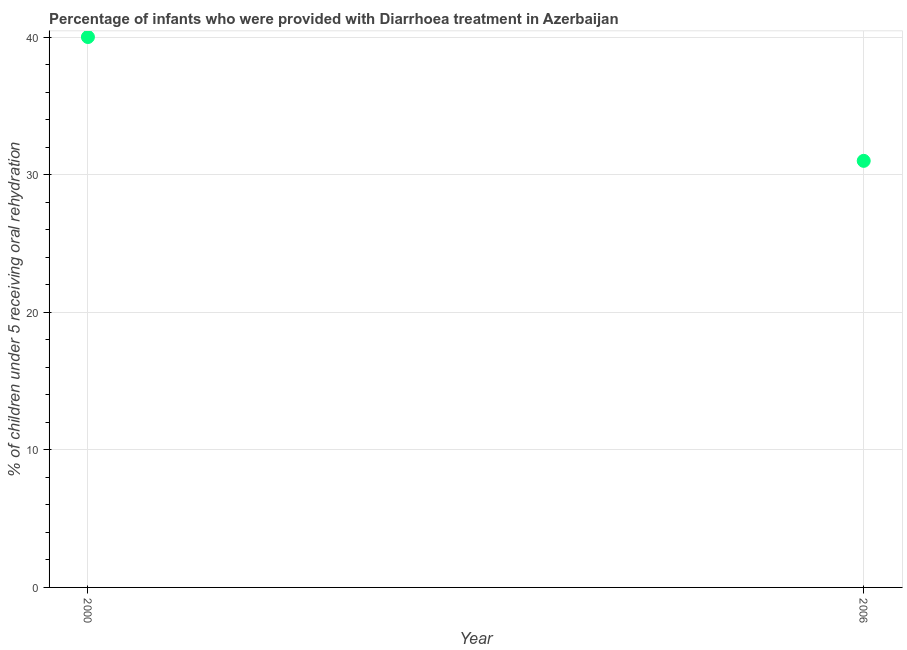What is the percentage of children who were provided with treatment diarrhoea in 2006?
Ensure brevity in your answer.  31. Across all years, what is the maximum percentage of children who were provided with treatment diarrhoea?
Ensure brevity in your answer.  40. Across all years, what is the minimum percentage of children who were provided with treatment diarrhoea?
Keep it short and to the point. 31. What is the sum of the percentage of children who were provided with treatment diarrhoea?
Ensure brevity in your answer.  71. What is the difference between the percentage of children who were provided with treatment diarrhoea in 2000 and 2006?
Your response must be concise. 9. What is the average percentage of children who were provided with treatment diarrhoea per year?
Keep it short and to the point. 35.5. What is the median percentage of children who were provided with treatment diarrhoea?
Make the answer very short. 35.5. In how many years, is the percentage of children who were provided with treatment diarrhoea greater than 10 %?
Ensure brevity in your answer.  2. Do a majority of the years between 2000 and 2006 (inclusive) have percentage of children who were provided with treatment diarrhoea greater than 30 %?
Your answer should be compact. Yes. What is the ratio of the percentage of children who were provided with treatment diarrhoea in 2000 to that in 2006?
Ensure brevity in your answer.  1.29. Does the percentage of children who were provided with treatment diarrhoea monotonically increase over the years?
Keep it short and to the point. No. How many dotlines are there?
Your response must be concise. 1. How many years are there in the graph?
Offer a very short reply. 2. Are the values on the major ticks of Y-axis written in scientific E-notation?
Give a very brief answer. No. What is the title of the graph?
Your response must be concise. Percentage of infants who were provided with Diarrhoea treatment in Azerbaijan. What is the label or title of the X-axis?
Your response must be concise. Year. What is the label or title of the Y-axis?
Provide a short and direct response. % of children under 5 receiving oral rehydration. What is the ratio of the % of children under 5 receiving oral rehydration in 2000 to that in 2006?
Make the answer very short. 1.29. 